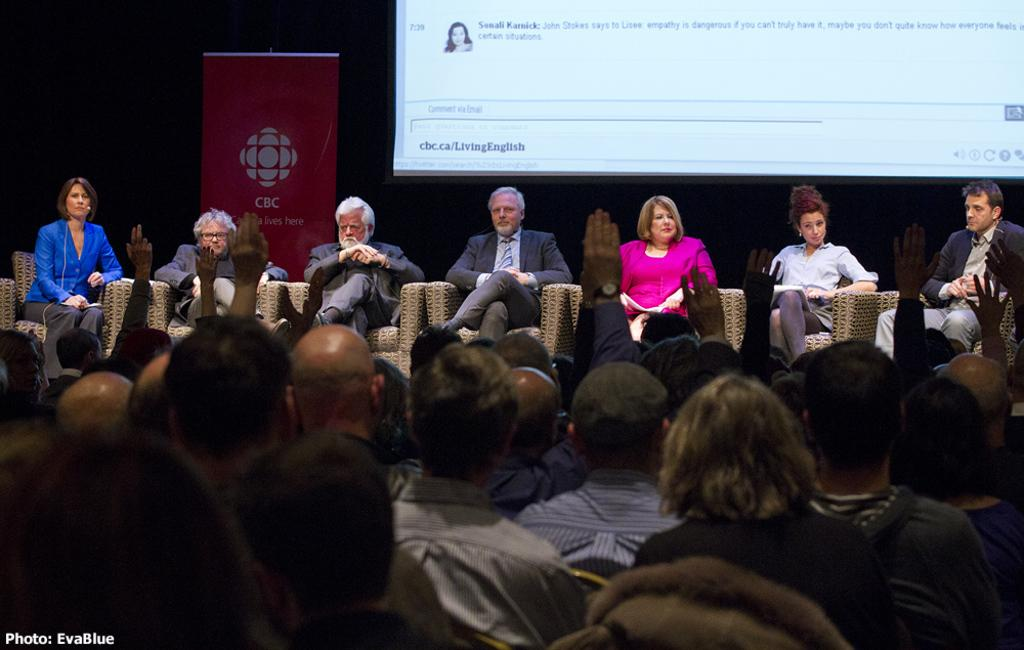Who or what can be seen in the image? There are people in the image. What objects are present that the people might sit on? There are chairs in the image. Is there any additional information provided by the banner? Yes, there is a banner in the image. What is in the pocket of the person on the side in the image? There is no information about pockets or a person on the side in the image. 